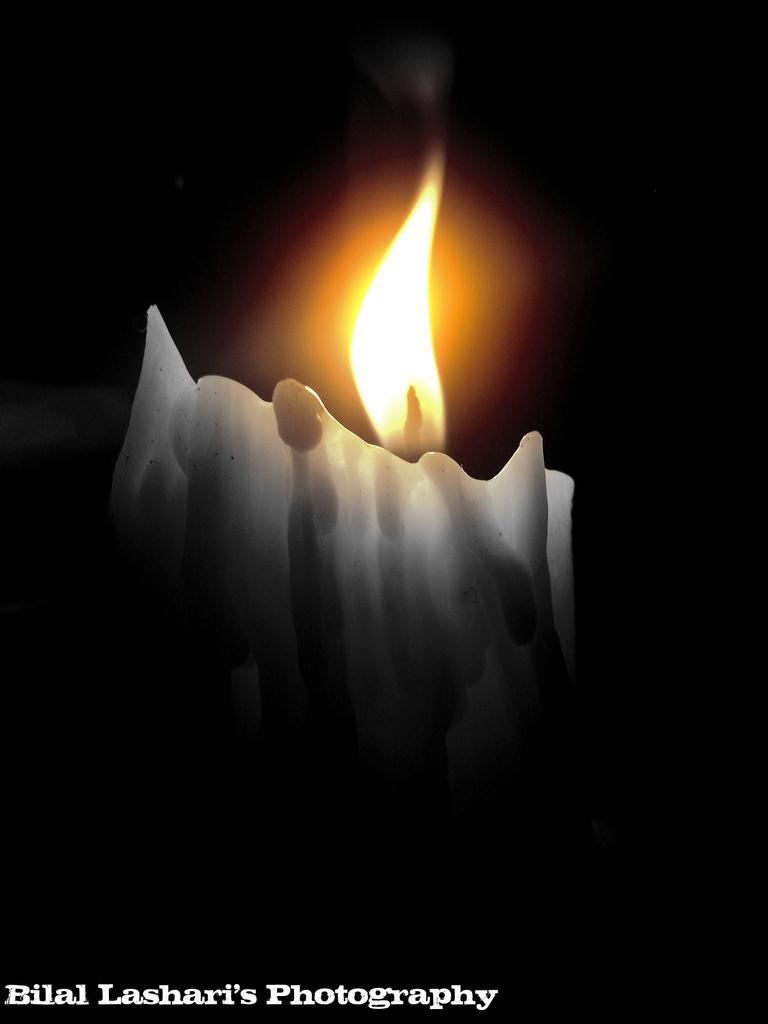What object is present in the image that produces light? There is a candle in the image that produces light. What is the state of the candle's flame in the image? The candle has a flame in the image. How would you describe the overall lighting in the image? The background of the image is dark. Where can text be found in the image? There is text in the bottom left corner of the image. How many deer are visible in the image? There are no deer present in the image. What type of prose is written in the text of the image? There is no prose present in the image, as the text is not described in the provided facts. 